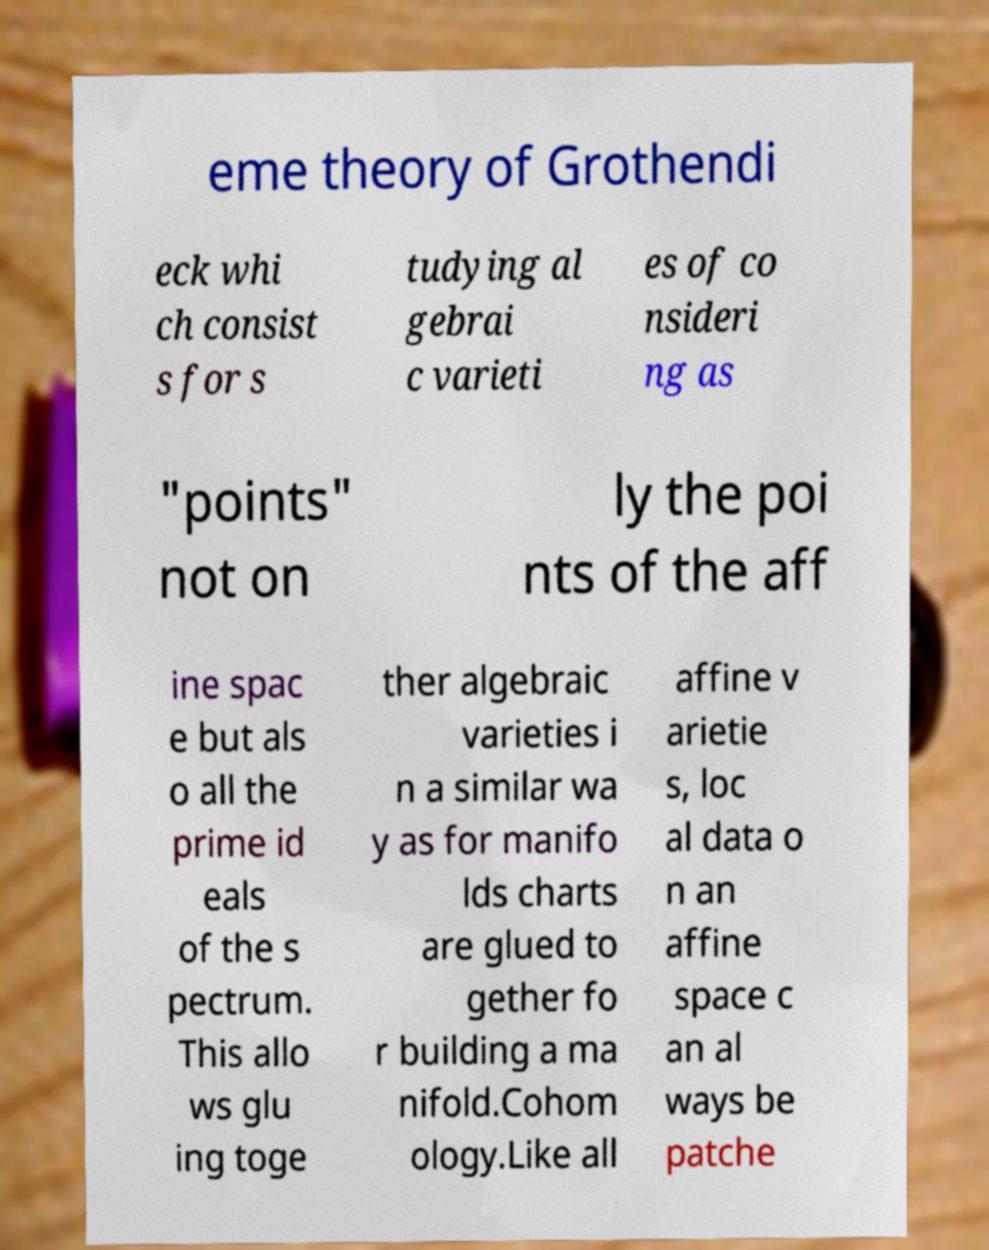Could you assist in decoding the text presented in this image and type it out clearly? eme theory of Grothendi eck whi ch consist s for s tudying al gebrai c varieti es of co nsideri ng as "points" not on ly the poi nts of the aff ine spac e but als o all the prime id eals of the s pectrum. This allo ws glu ing toge ther algebraic varieties i n a similar wa y as for manifo lds charts are glued to gether fo r building a ma nifold.Cohom ology.Like all affine v arietie s, loc al data o n an affine space c an al ways be patche 